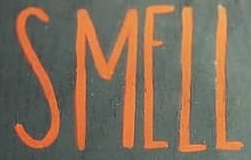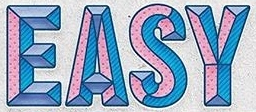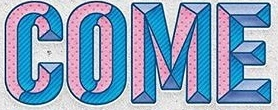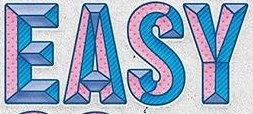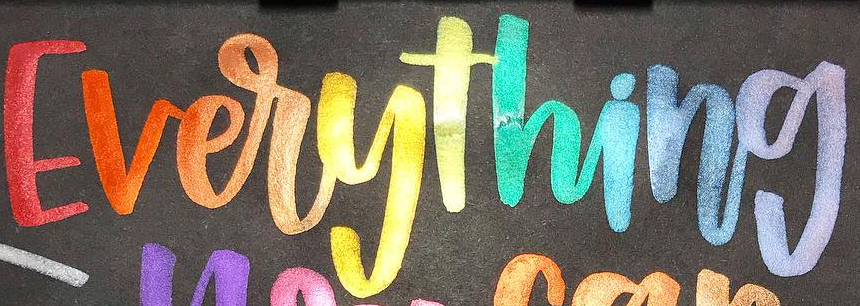What words can you see in these images in sequence, separated by a semicolon? SMELL; EASY; COME; EASY; Everything 